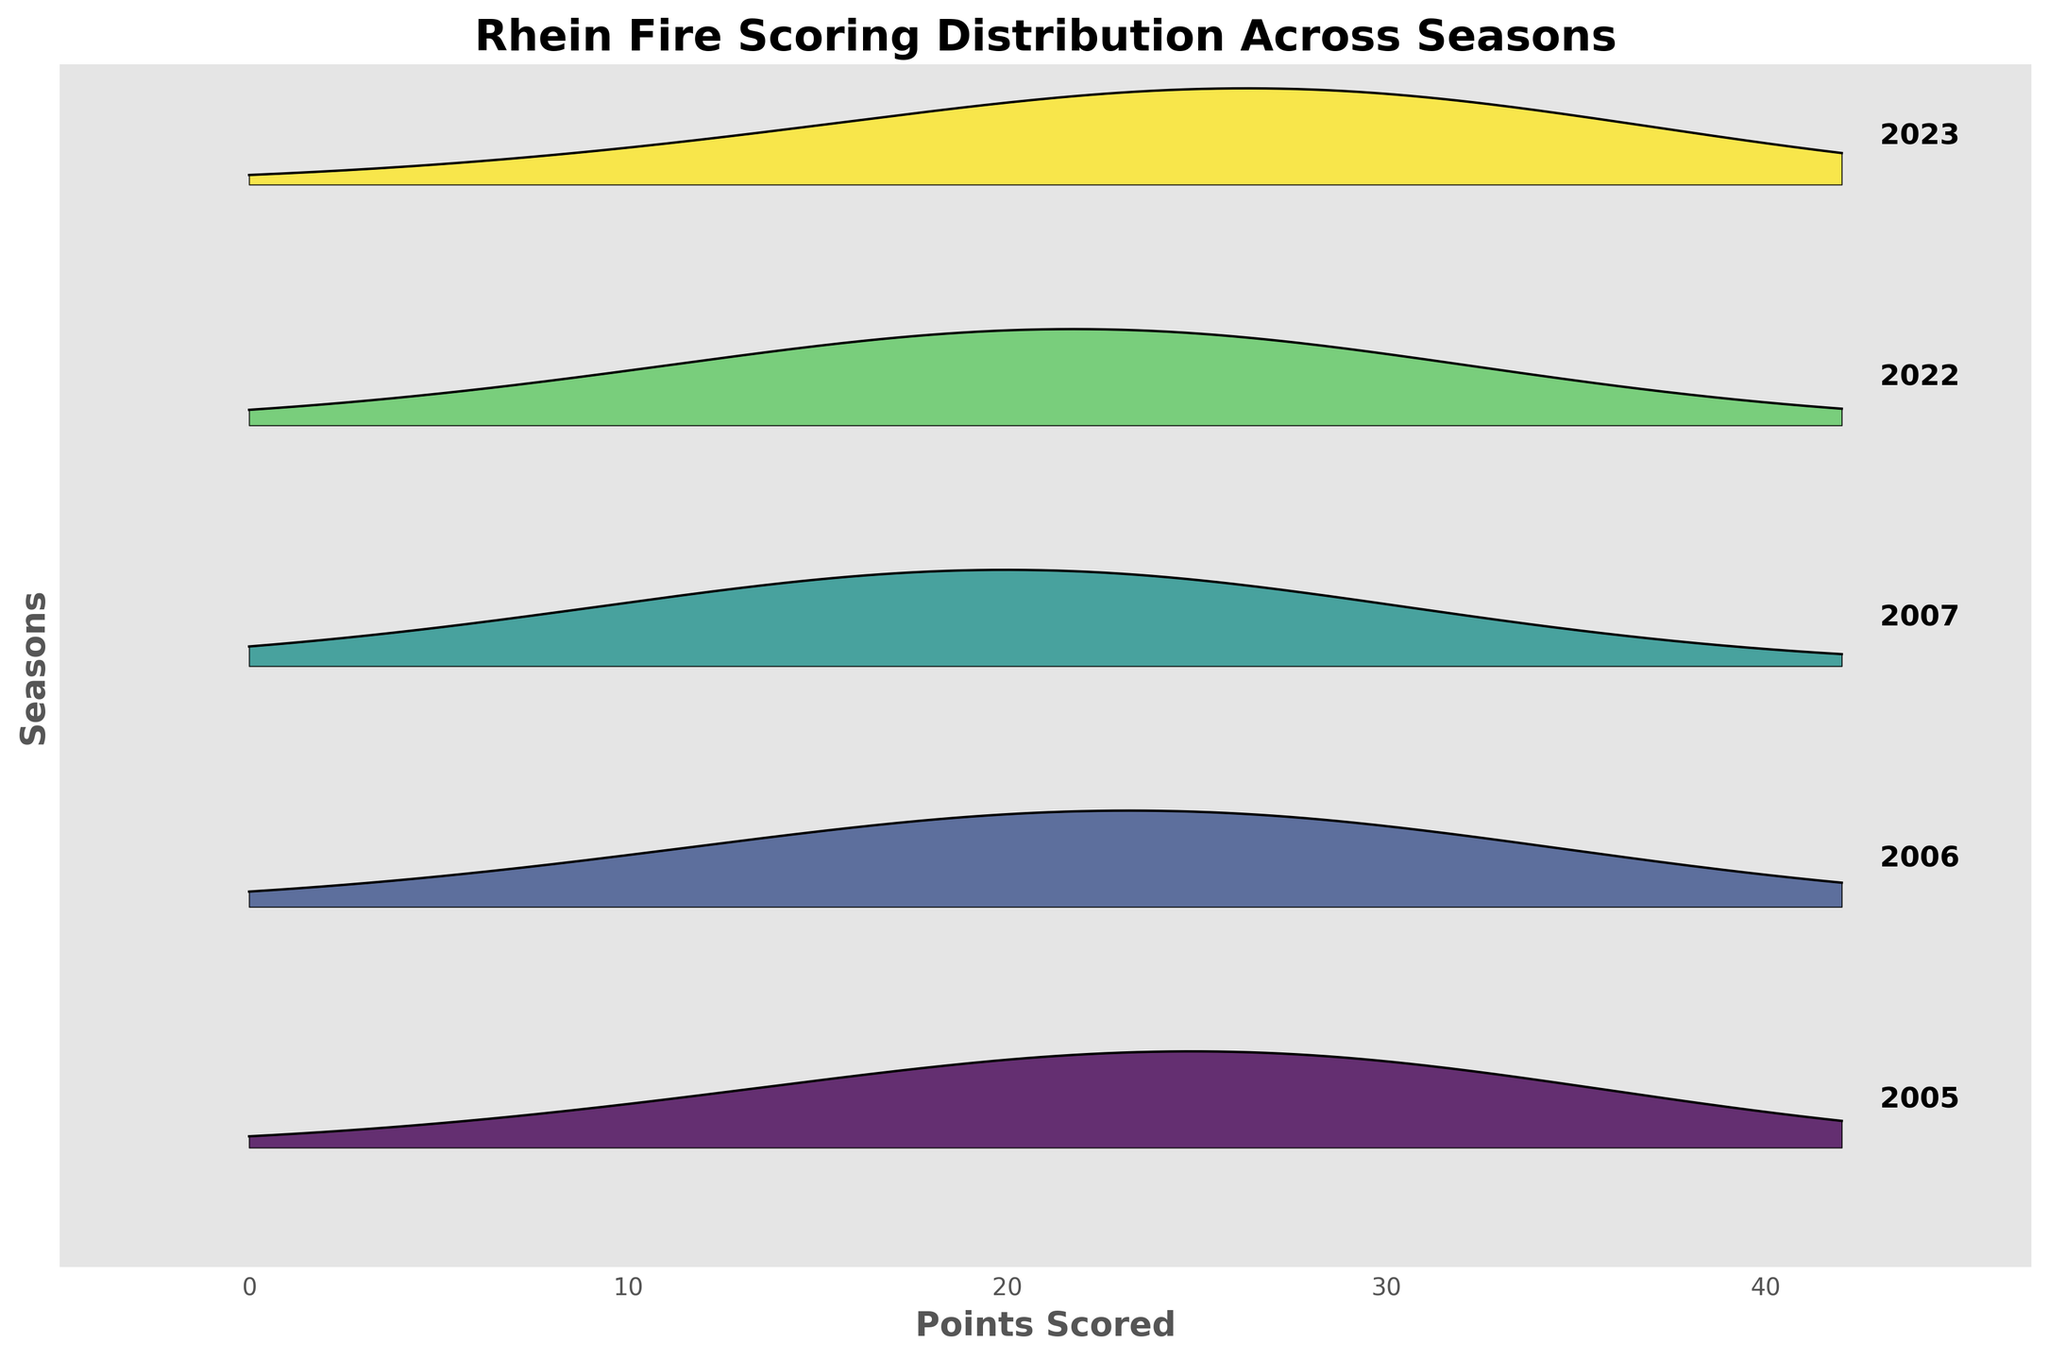What is the title of the plot? The title is typically found at the top of the plot and describes the contents of the visualization. For this plot, the title is displayed prominently.
Answer: "Rhein Fire Scoring Distribution Across Seasons" Which season has the highest density around 28 points? Find the season curve that has the highest peak around the 28 points mark by examining the plot visually. The highest peak indicates the season with the most frequent scoring around that value.
Answer: 2023 How does the density distribution in 2023 for 35 points compare to that in 2006? Compare the heights of the curves at the 35 points mark for the years 2023 and 2006. The year with the higher curve has a higher density at that point.
Answer: 2023 has a higher density than 2006 What range of points has the highest density across all seasons? Identify the data point range where the highest peaks across all seasons are located. Typically, this represents the most common scoring range.
Answer: 21-28 points Which season seems to have the most balanced scoring distribution across different points? Look for the curve that has a relatively even distribution across a range of points without sharp peaks, indicating balanced scoring throughout the season.
Answer: 2005 What is the lowest density value recorded and in which season does it occur? Examine the y-axis and find the lowest density value on the plot, then note the associated season. This can be observed from the least prominent sections of the curves.
Answer: 0.01, 2023 and 2005 Which seasons' scoring distributions have a noticeable peak at 21 points? Look for curves with a visible peak at the 21 points mark. Peaks indicate frequent scoring at that point.
Answer: 2023, 2022, 2007, 2006 How does the scoring distribution in 2007 compare to 2022 at 14 points? Compare the densities of the 2007 and 2022 curves at the 14 points mark to determine which season had more frequent scoring at that value.
Answer: 2007 has a higher density What is the shape of the scoring distribution curve for 2005? Describe the general appearance of the 2005 curve. Look for features like the number and location of peaks and overall smoothness.
Answer: One major peak around 28 points with a relatively smooth decline on either side Does any season have a scoring distribution peak at 42 points? Check if there is any curve that peaks or has a noticeable height at the 42 points mark to identify frequent high scores for that season.
Answer: No season has a peak at 42 points 